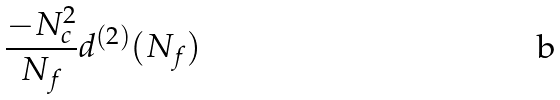Convert formula to latex. <formula><loc_0><loc_0><loc_500><loc_500>\frac { - N _ { c } ^ { 2 } } { N _ { f } } d ^ { ( 2 ) } ( N _ { f } )</formula> 